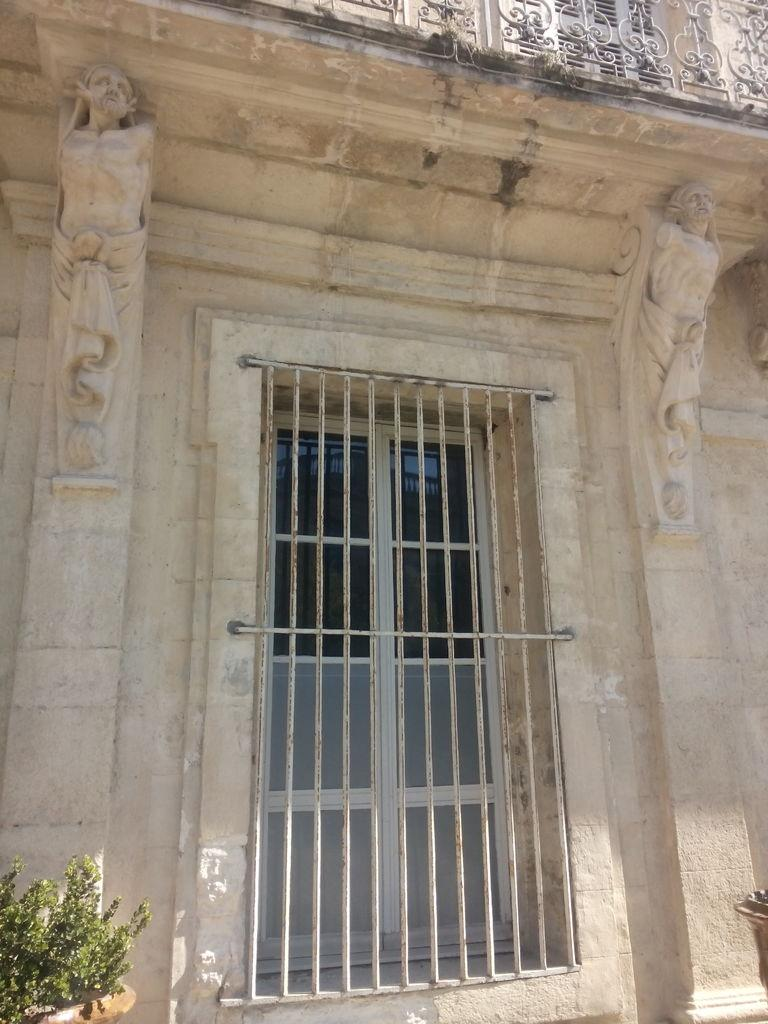What architectural feature can be seen in the image? There is a window in the image. What decorative elements are present near the window? There are two sculptures on the wall, one on each side of the window. What type of vegetation is visible in the image? There is a plant on the left side of the image. What type of engine can be seen powering the sculptures in the image? There is no engine present in the image; the sculptures are stationary decorative elements. 